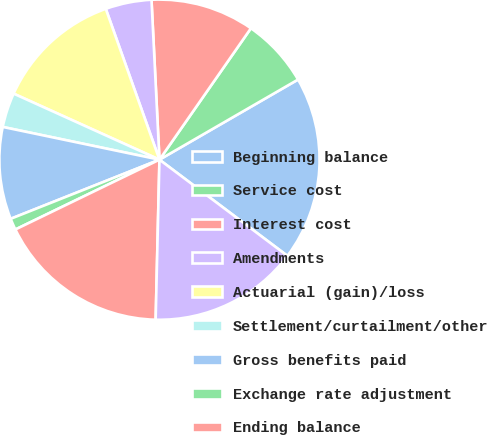<chart> <loc_0><loc_0><loc_500><loc_500><pie_chart><fcel>Beginning balance<fcel>Service cost<fcel>Interest cost<fcel>Amendments<fcel>Actuarial (gain)/loss<fcel>Settlement/curtailment/other<fcel>Gross benefits paid<fcel>Exchange rate adjustment<fcel>Ending balance<fcel>Beginning balance at fair<nl><fcel>18.6%<fcel>6.98%<fcel>10.47%<fcel>4.65%<fcel>12.79%<fcel>3.49%<fcel>9.3%<fcel>1.16%<fcel>17.44%<fcel>15.12%<nl></chart> 